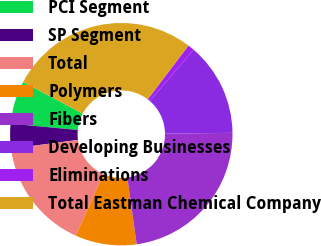<chart> <loc_0><loc_0><loc_500><loc_500><pie_chart><fcel>PCI Segment<fcel>SP Segment<fcel>Total<fcel>Polymers<fcel>Fibers<fcel>Developing Businesses<fcel>Eliminations<fcel>Total Eastman Chemical Company<nl><fcel>6.26%<fcel>3.6%<fcel>16.2%<fcel>8.92%<fcel>22.98%<fcel>13.54%<fcel>0.94%<fcel>27.55%<nl></chart> 